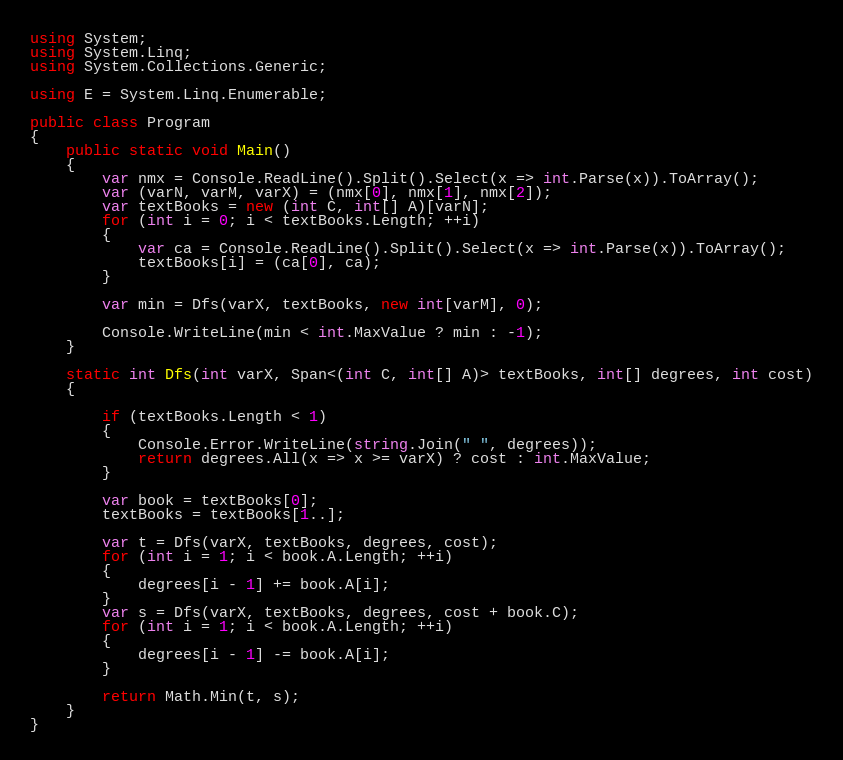Convert code to text. <code><loc_0><loc_0><loc_500><loc_500><_C#_>using System;
using System.Linq;
using System.Collections.Generic;

using E = System.Linq.Enumerable;

public class Program
{
    public static void Main()
    {
        var nmx = Console.ReadLine().Split().Select(x => int.Parse(x)).ToArray();
        var (varN, varM, varX) = (nmx[0], nmx[1], nmx[2]);
        var textBooks = new (int C, int[] A)[varN];
        for (int i = 0; i < textBooks.Length; ++i)
        {
            var ca = Console.ReadLine().Split().Select(x => int.Parse(x)).ToArray();
            textBooks[i] = (ca[0], ca);
        }

        var min = Dfs(varX, textBooks, new int[varM], 0);

        Console.WriteLine(min < int.MaxValue ? min : -1);
    }

    static int Dfs(int varX, Span<(int C, int[] A)> textBooks, int[] degrees, int cost)
    {

        if (textBooks.Length < 1)
        {
            Console.Error.WriteLine(string.Join(" ", degrees));
            return degrees.All(x => x >= varX) ? cost : int.MaxValue;
        }

        var book = textBooks[0];
        textBooks = textBooks[1..];

        var t = Dfs(varX, textBooks, degrees, cost);
        for (int i = 1; i < book.A.Length; ++i)
        {
            degrees[i - 1] += book.A[i];
        }
        var s = Dfs(varX, textBooks, degrees, cost + book.C);
        for (int i = 1; i < book.A.Length; ++i)
        {
            degrees[i - 1] -= book.A[i];
        }

        return Math.Min(t, s);
    }
}
</code> 